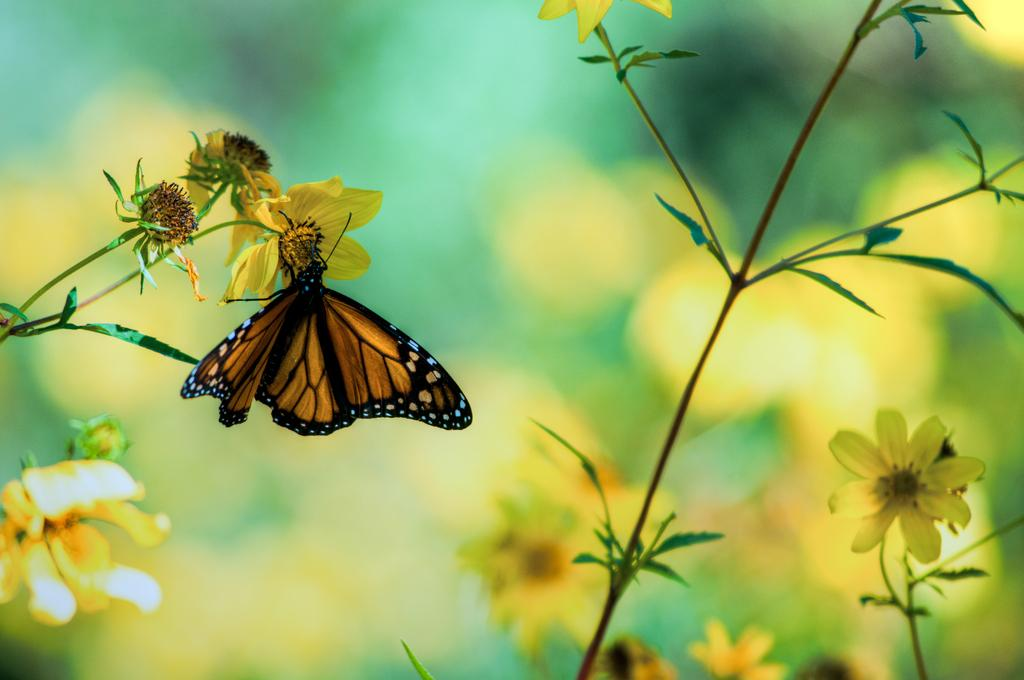What is the main subject of the image? The main subject of the image is a butterfly. Where is the butterfly located in the image? The butterfly is on a yellow flower. What type of flowers are present in the image? There are yellow flowers in the image. Are the flowers part of a larger plant? Yes, the flowers are part of a plant. Can you describe the background of the image? The background of the image is blurred. What type of zipper can be seen on the butterfly's wings in the image? There is no zipper present on the butterfly's wings in the image. Is there any steam visible in the image? There is no steam present in the image. 